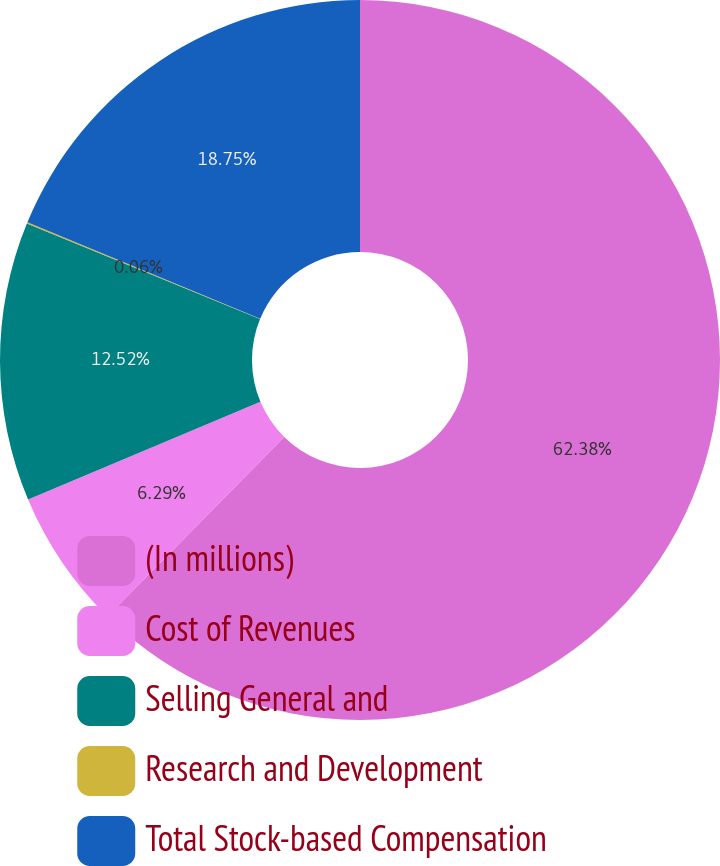Convert chart to OTSL. <chart><loc_0><loc_0><loc_500><loc_500><pie_chart><fcel>(In millions)<fcel>Cost of Revenues<fcel>Selling General and<fcel>Research and Development<fcel>Total Stock-based Compensation<nl><fcel>62.38%<fcel>6.29%<fcel>12.52%<fcel>0.06%<fcel>18.75%<nl></chart> 